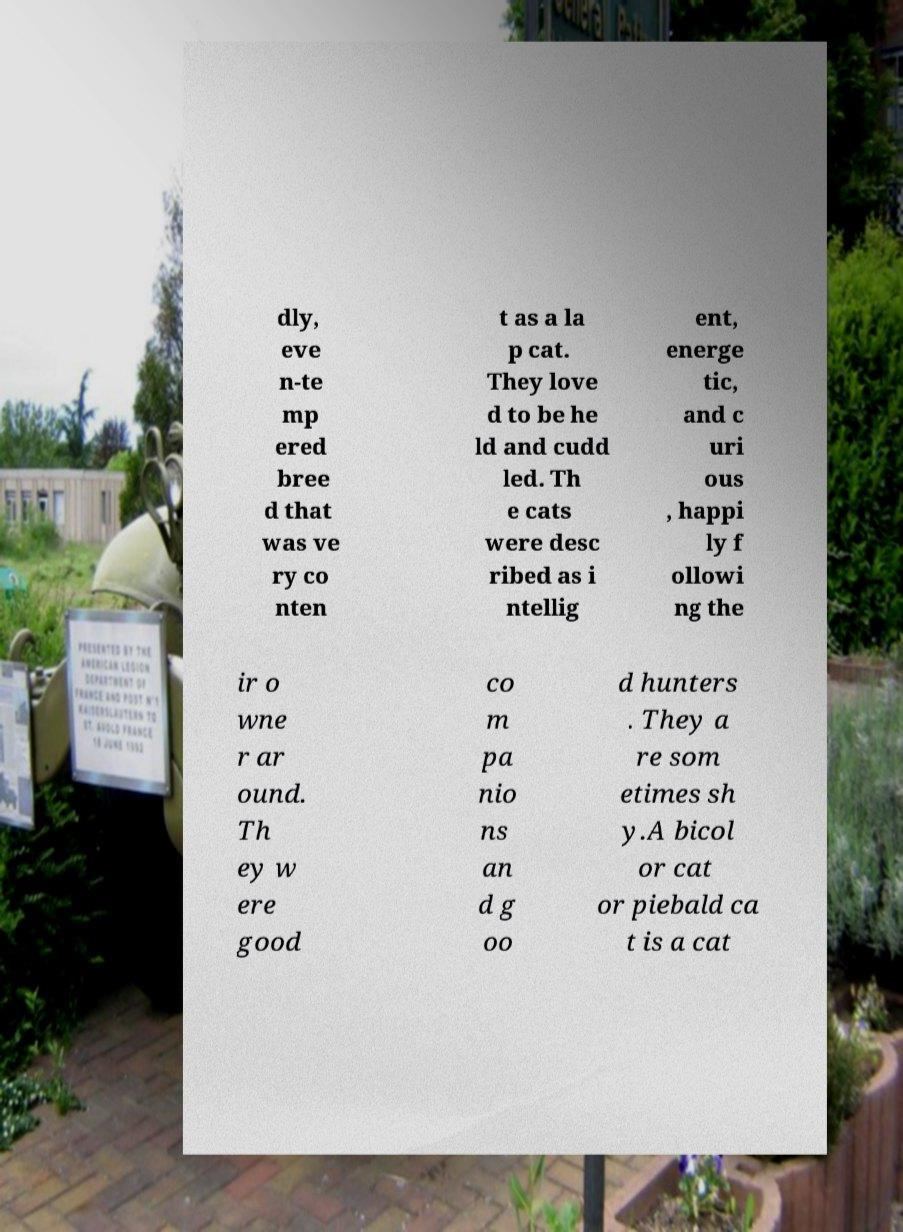Please identify and transcribe the text found in this image. dly, eve n-te mp ered bree d that was ve ry co nten t as a la p cat. They love d to be he ld and cudd led. Th e cats were desc ribed as i ntellig ent, energe tic, and c uri ous , happi ly f ollowi ng the ir o wne r ar ound. Th ey w ere good co m pa nio ns an d g oo d hunters . They a re som etimes sh y.A bicol or cat or piebald ca t is a cat 